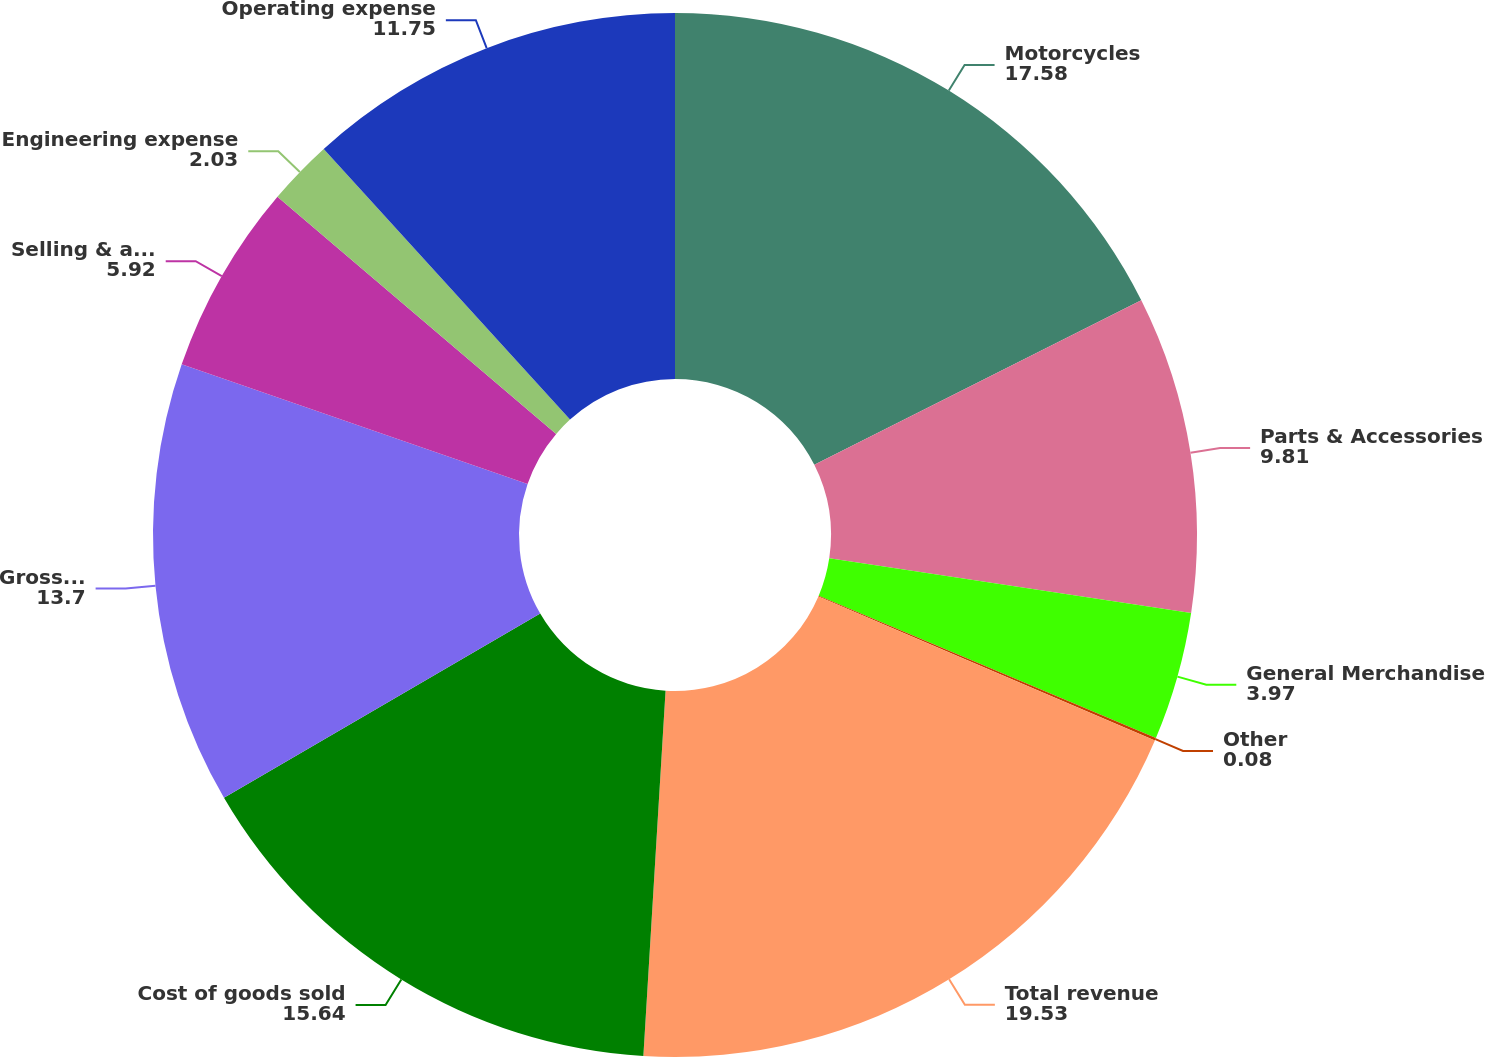<chart> <loc_0><loc_0><loc_500><loc_500><pie_chart><fcel>Motorcycles<fcel>Parts & Accessories<fcel>General Merchandise<fcel>Other<fcel>Total revenue<fcel>Cost of goods sold<fcel>Gross profit<fcel>Selling & administrative<fcel>Engineering expense<fcel>Operating expense<nl><fcel>17.58%<fcel>9.81%<fcel>3.97%<fcel>0.08%<fcel>19.53%<fcel>15.64%<fcel>13.7%<fcel>5.92%<fcel>2.03%<fcel>11.75%<nl></chart> 